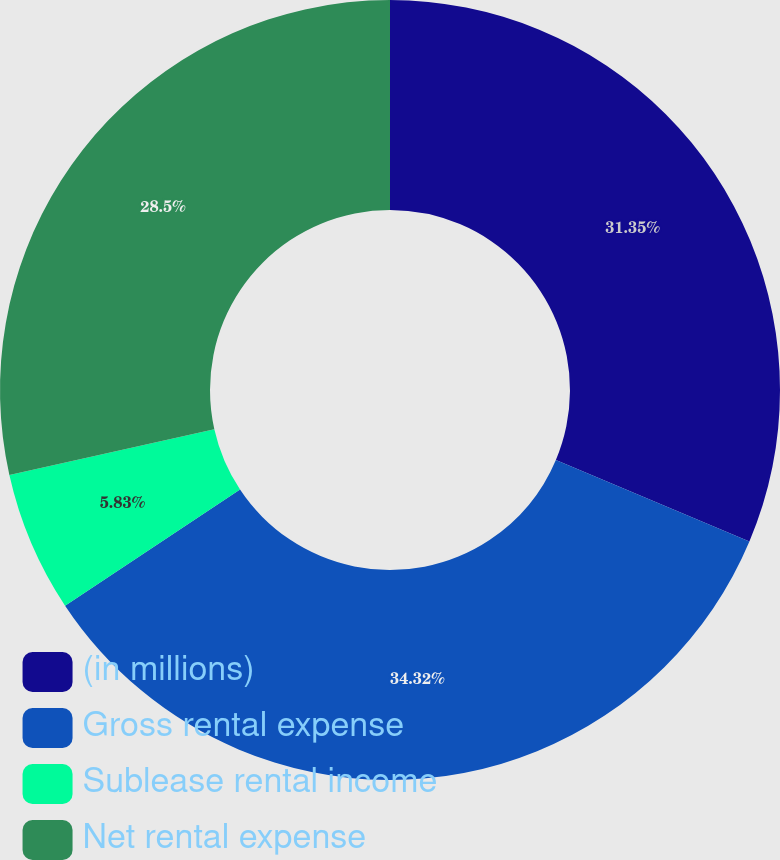Convert chart. <chart><loc_0><loc_0><loc_500><loc_500><pie_chart><fcel>(in millions)<fcel>Gross rental expense<fcel>Sublease rental income<fcel>Net rental expense<nl><fcel>31.35%<fcel>34.33%<fcel>5.83%<fcel>28.5%<nl></chart> 